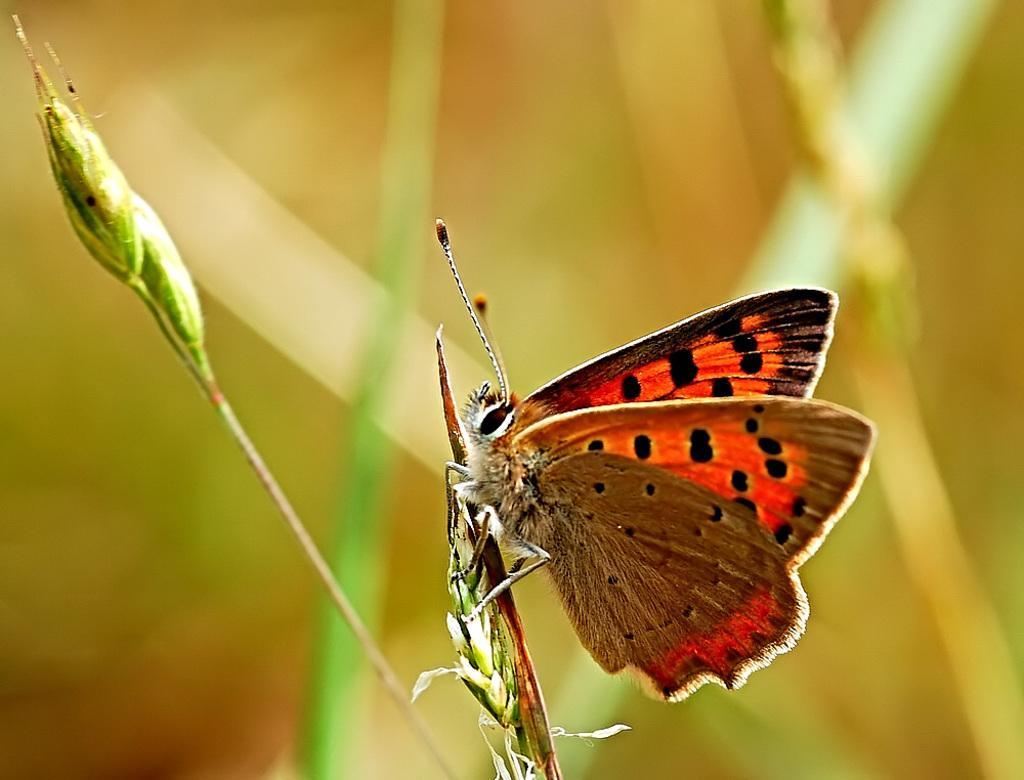How would you summarize this image in a sentence or two? In this image we can see buds and there is a butterfly on the bud and a blurry background. 